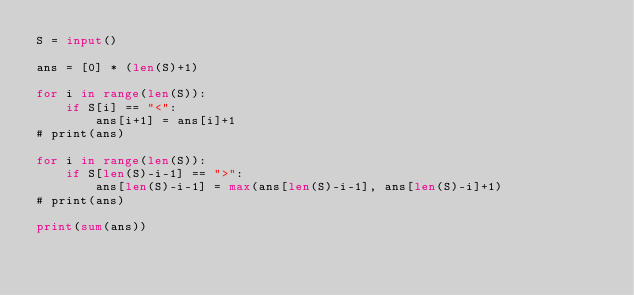<code> <loc_0><loc_0><loc_500><loc_500><_Python_>S = input()

ans = [0] * (len(S)+1)

for i in range(len(S)):
    if S[i] == "<":
        ans[i+1] = ans[i]+1
# print(ans)

for i in range(len(S)):
    if S[len(S)-i-1] == ">":
        ans[len(S)-i-1] = max(ans[len(S)-i-1], ans[len(S)-i]+1)
# print(ans)

print(sum(ans))
</code> 